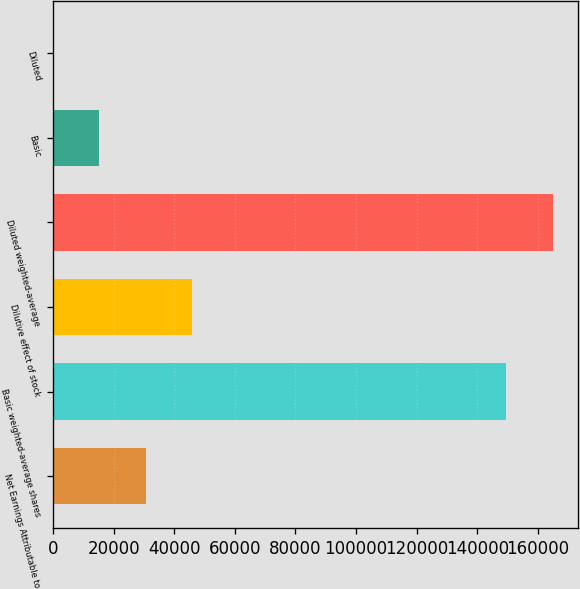Convert chart to OTSL. <chart><loc_0><loc_0><loc_500><loc_500><bar_chart><fcel>Net Earnings Attributable to<fcel>Basic weighted-average shares<fcel>Dilutive effect of stock<fcel>Diluted weighted-average<fcel>Basic<fcel>Diluted<nl><fcel>30496.2<fcel>149629<fcel>45740.3<fcel>164873<fcel>15252.1<fcel>8.05<nl></chart> 